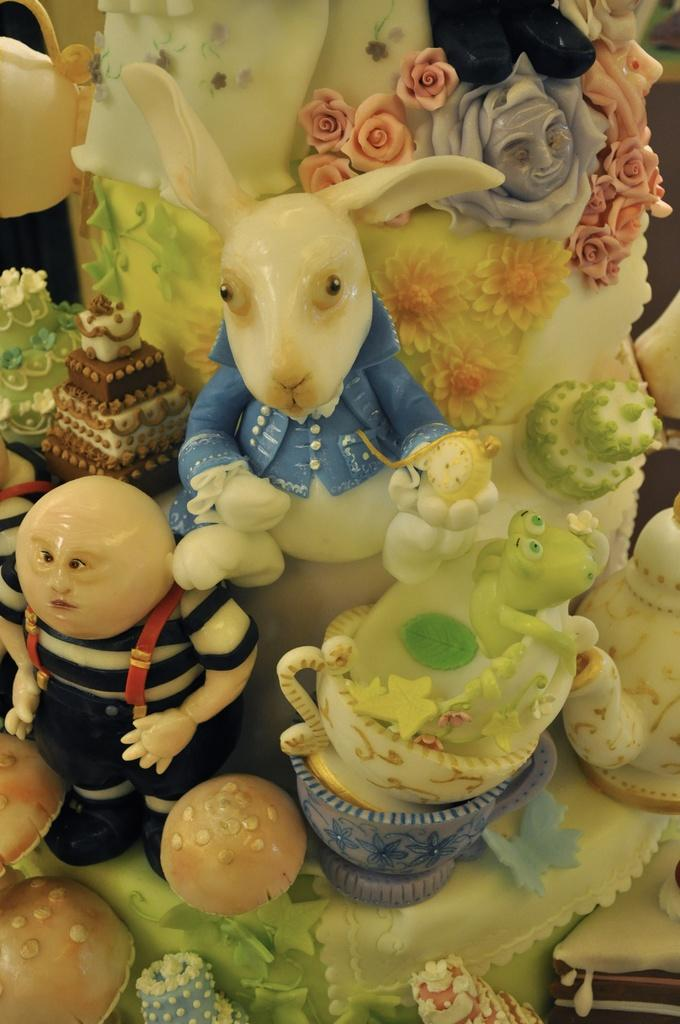What is located in the center of the image? There are toys in the center of the image. Can you tell me how many donkeys are playing with the toys in the image? There are no donkeys present in the image; it only features toys. What type of apparel is the yard wearing in the image? There is no yard or apparel present in the image, as the image only contains toys. 